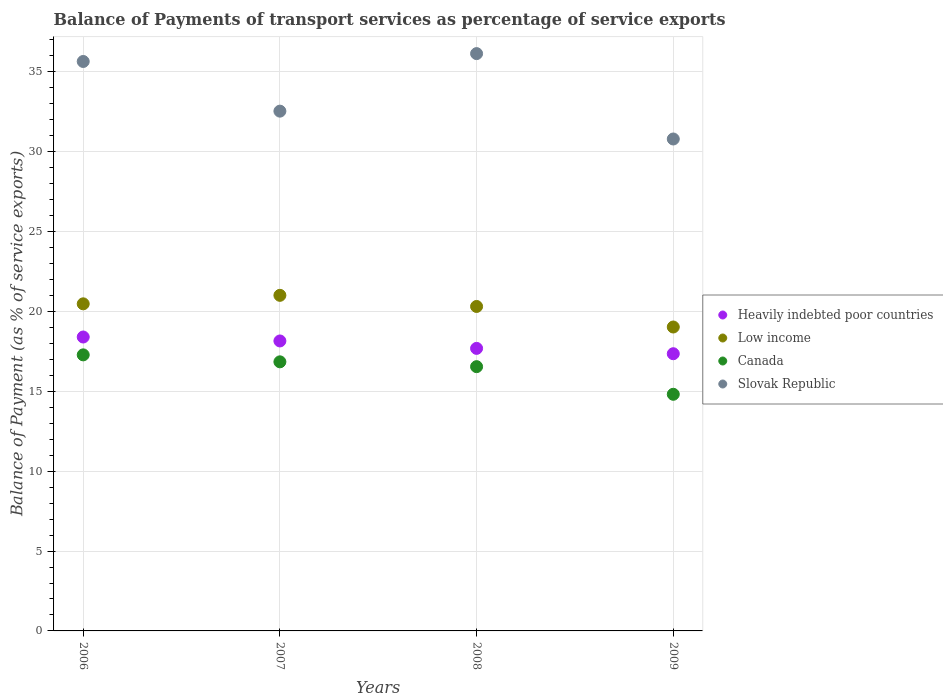How many different coloured dotlines are there?
Your response must be concise. 4. Is the number of dotlines equal to the number of legend labels?
Provide a short and direct response. Yes. What is the balance of payments of transport services in Slovak Republic in 2009?
Offer a very short reply. 30.8. Across all years, what is the maximum balance of payments of transport services in Canada?
Offer a terse response. 17.28. Across all years, what is the minimum balance of payments of transport services in Slovak Republic?
Make the answer very short. 30.8. In which year was the balance of payments of transport services in Heavily indebted poor countries maximum?
Your response must be concise. 2006. What is the total balance of payments of transport services in Canada in the graph?
Your answer should be compact. 65.49. What is the difference between the balance of payments of transport services in Low income in 2006 and that in 2008?
Your answer should be very brief. 0.16. What is the difference between the balance of payments of transport services in Slovak Republic in 2006 and the balance of payments of transport services in Canada in 2007?
Keep it short and to the point. 18.8. What is the average balance of payments of transport services in Heavily indebted poor countries per year?
Offer a very short reply. 17.9. In the year 2009, what is the difference between the balance of payments of transport services in Low income and balance of payments of transport services in Canada?
Keep it short and to the point. 4.21. In how many years, is the balance of payments of transport services in Slovak Republic greater than 8 %?
Offer a terse response. 4. What is the ratio of the balance of payments of transport services in Slovak Republic in 2007 to that in 2009?
Provide a short and direct response. 1.06. Is the balance of payments of transport services in Slovak Republic in 2007 less than that in 2009?
Give a very brief answer. No. What is the difference between the highest and the second highest balance of payments of transport services in Slovak Republic?
Give a very brief answer. 0.49. What is the difference between the highest and the lowest balance of payments of transport services in Heavily indebted poor countries?
Provide a short and direct response. 1.05. Is it the case that in every year, the sum of the balance of payments of transport services in Low income and balance of payments of transport services in Heavily indebted poor countries  is greater than the balance of payments of transport services in Slovak Republic?
Your answer should be very brief. Yes. Does the balance of payments of transport services in Heavily indebted poor countries monotonically increase over the years?
Offer a terse response. No. Is the balance of payments of transport services in Slovak Republic strictly greater than the balance of payments of transport services in Low income over the years?
Your answer should be very brief. Yes. Are the values on the major ticks of Y-axis written in scientific E-notation?
Offer a terse response. No. Does the graph contain any zero values?
Give a very brief answer. No. How many legend labels are there?
Provide a short and direct response. 4. What is the title of the graph?
Offer a terse response. Balance of Payments of transport services as percentage of service exports. What is the label or title of the Y-axis?
Your answer should be compact. Balance of Payment (as % of service exports). What is the Balance of Payment (as % of service exports) of Heavily indebted poor countries in 2006?
Keep it short and to the point. 18.4. What is the Balance of Payment (as % of service exports) of Low income in 2006?
Your response must be concise. 20.48. What is the Balance of Payment (as % of service exports) of Canada in 2006?
Ensure brevity in your answer.  17.28. What is the Balance of Payment (as % of service exports) of Slovak Republic in 2006?
Give a very brief answer. 35.65. What is the Balance of Payment (as % of service exports) of Heavily indebted poor countries in 2007?
Offer a very short reply. 18.15. What is the Balance of Payment (as % of service exports) in Low income in 2007?
Offer a very short reply. 21.01. What is the Balance of Payment (as % of service exports) of Canada in 2007?
Give a very brief answer. 16.85. What is the Balance of Payment (as % of service exports) in Slovak Republic in 2007?
Your response must be concise. 32.54. What is the Balance of Payment (as % of service exports) of Heavily indebted poor countries in 2008?
Give a very brief answer. 17.69. What is the Balance of Payment (as % of service exports) in Low income in 2008?
Make the answer very short. 20.31. What is the Balance of Payment (as % of service exports) of Canada in 2008?
Ensure brevity in your answer.  16.55. What is the Balance of Payment (as % of service exports) in Slovak Republic in 2008?
Keep it short and to the point. 36.14. What is the Balance of Payment (as % of service exports) of Heavily indebted poor countries in 2009?
Your answer should be very brief. 17.36. What is the Balance of Payment (as % of service exports) in Low income in 2009?
Ensure brevity in your answer.  19.03. What is the Balance of Payment (as % of service exports) in Canada in 2009?
Your answer should be very brief. 14.82. What is the Balance of Payment (as % of service exports) in Slovak Republic in 2009?
Make the answer very short. 30.8. Across all years, what is the maximum Balance of Payment (as % of service exports) in Heavily indebted poor countries?
Keep it short and to the point. 18.4. Across all years, what is the maximum Balance of Payment (as % of service exports) in Low income?
Your response must be concise. 21.01. Across all years, what is the maximum Balance of Payment (as % of service exports) in Canada?
Provide a short and direct response. 17.28. Across all years, what is the maximum Balance of Payment (as % of service exports) of Slovak Republic?
Offer a very short reply. 36.14. Across all years, what is the minimum Balance of Payment (as % of service exports) in Heavily indebted poor countries?
Make the answer very short. 17.36. Across all years, what is the minimum Balance of Payment (as % of service exports) of Low income?
Keep it short and to the point. 19.03. Across all years, what is the minimum Balance of Payment (as % of service exports) of Canada?
Make the answer very short. 14.82. Across all years, what is the minimum Balance of Payment (as % of service exports) of Slovak Republic?
Provide a succinct answer. 30.8. What is the total Balance of Payment (as % of service exports) in Heavily indebted poor countries in the graph?
Your response must be concise. 71.6. What is the total Balance of Payment (as % of service exports) in Low income in the graph?
Provide a short and direct response. 80.83. What is the total Balance of Payment (as % of service exports) of Canada in the graph?
Provide a short and direct response. 65.49. What is the total Balance of Payment (as % of service exports) in Slovak Republic in the graph?
Give a very brief answer. 135.14. What is the difference between the Balance of Payment (as % of service exports) in Heavily indebted poor countries in 2006 and that in 2007?
Offer a terse response. 0.25. What is the difference between the Balance of Payment (as % of service exports) of Low income in 2006 and that in 2007?
Offer a very short reply. -0.53. What is the difference between the Balance of Payment (as % of service exports) of Canada in 2006 and that in 2007?
Provide a short and direct response. 0.44. What is the difference between the Balance of Payment (as % of service exports) in Slovak Republic in 2006 and that in 2007?
Offer a terse response. 3.11. What is the difference between the Balance of Payment (as % of service exports) of Heavily indebted poor countries in 2006 and that in 2008?
Provide a succinct answer. 0.71. What is the difference between the Balance of Payment (as % of service exports) of Low income in 2006 and that in 2008?
Keep it short and to the point. 0.16. What is the difference between the Balance of Payment (as % of service exports) of Canada in 2006 and that in 2008?
Keep it short and to the point. 0.74. What is the difference between the Balance of Payment (as % of service exports) of Slovak Republic in 2006 and that in 2008?
Make the answer very short. -0.49. What is the difference between the Balance of Payment (as % of service exports) in Heavily indebted poor countries in 2006 and that in 2009?
Offer a very short reply. 1.05. What is the difference between the Balance of Payment (as % of service exports) of Low income in 2006 and that in 2009?
Your answer should be compact. 1.45. What is the difference between the Balance of Payment (as % of service exports) of Canada in 2006 and that in 2009?
Provide a succinct answer. 2.47. What is the difference between the Balance of Payment (as % of service exports) in Slovak Republic in 2006 and that in 2009?
Keep it short and to the point. 4.85. What is the difference between the Balance of Payment (as % of service exports) in Heavily indebted poor countries in 2007 and that in 2008?
Your answer should be very brief. 0.47. What is the difference between the Balance of Payment (as % of service exports) of Low income in 2007 and that in 2008?
Your answer should be very brief. 0.7. What is the difference between the Balance of Payment (as % of service exports) in Canada in 2007 and that in 2008?
Keep it short and to the point. 0.3. What is the difference between the Balance of Payment (as % of service exports) in Slovak Republic in 2007 and that in 2008?
Ensure brevity in your answer.  -3.6. What is the difference between the Balance of Payment (as % of service exports) of Heavily indebted poor countries in 2007 and that in 2009?
Provide a succinct answer. 0.8. What is the difference between the Balance of Payment (as % of service exports) in Low income in 2007 and that in 2009?
Your answer should be compact. 1.98. What is the difference between the Balance of Payment (as % of service exports) in Canada in 2007 and that in 2009?
Offer a very short reply. 2.03. What is the difference between the Balance of Payment (as % of service exports) of Slovak Republic in 2007 and that in 2009?
Make the answer very short. 1.74. What is the difference between the Balance of Payment (as % of service exports) in Heavily indebted poor countries in 2008 and that in 2009?
Provide a short and direct response. 0.33. What is the difference between the Balance of Payment (as % of service exports) of Low income in 2008 and that in 2009?
Your answer should be very brief. 1.29. What is the difference between the Balance of Payment (as % of service exports) of Canada in 2008 and that in 2009?
Keep it short and to the point. 1.73. What is the difference between the Balance of Payment (as % of service exports) of Slovak Republic in 2008 and that in 2009?
Give a very brief answer. 5.35. What is the difference between the Balance of Payment (as % of service exports) in Heavily indebted poor countries in 2006 and the Balance of Payment (as % of service exports) in Low income in 2007?
Your answer should be compact. -2.61. What is the difference between the Balance of Payment (as % of service exports) of Heavily indebted poor countries in 2006 and the Balance of Payment (as % of service exports) of Canada in 2007?
Your answer should be compact. 1.55. What is the difference between the Balance of Payment (as % of service exports) in Heavily indebted poor countries in 2006 and the Balance of Payment (as % of service exports) in Slovak Republic in 2007?
Keep it short and to the point. -14.14. What is the difference between the Balance of Payment (as % of service exports) in Low income in 2006 and the Balance of Payment (as % of service exports) in Canada in 2007?
Your response must be concise. 3.63. What is the difference between the Balance of Payment (as % of service exports) of Low income in 2006 and the Balance of Payment (as % of service exports) of Slovak Republic in 2007?
Offer a very short reply. -12.06. What is the difference between the Balance of Payment (as % of service exports) of Canada in 2006 and the Balance of Payment (as % of service exports) of Slovak Republic in 2007?
Your answer should be very brief. -15.26. What is the difference between the Balance of Payment (as % of service exports) in Heavily indebted poor countries in 2006 and the Balance of Payment (as % of service exports) in Low income in 2008?
Provide a succinct answer. -1.91. What is the difference between the Balance of Payment (as % of service exports) in Heavily indebted poor countries in 2006 and the Balance of Payment (as % of service exports) in Canada in 2008?
Offer a terse response. 1.86. What is the difference between the Balance of Payment (as % of service exports) of Heavily indebted poor countries in 2006 and the Balance of Payment (as % of service exports) of Slovak Republic in 2008?
Offer a very short reply. -17.74. What is the difference between the Balance of Payment (as % of service exports) of Low income in 2006 and the Balance of Payment (as % of service exports) of Canada in 2008?
Give a very brief answer. 3.93. What is the difference between the Balance of Payment (as % of service exports) of Low income in 2006 and the Balance of Payment (as % of service exports) of Slovak Republic in 2008?
Your answer should be compact. -15.67. What is the difference between the Balance of Payment (as % of service exports) in Canada in 2006 and the Balance of Payment (as % of service exports) in Slovak Republic in 2008?
Your answer should be very brief. -18.86. What is the difference between the Balance of Payment (as % of service exports) in Heavily indebted poor countries in 2006 and the Balance of Payment (as % of service exports) in Low income in 2009?
Your answer should be compact. -0.63. What is the difference between the Balance of Payment (as % of service exports) in Heavily indebted poor countries in 2006 and the Balance of Payment (as % of service exports) in Canada in 2009?
Offer a terse response. 3.59. What is the difference between the Balance of Payment (as % of service exports) in Heavily indebted poor countries in 2006 and the Balance of Payment (as % of service exports) in Slovak Republic in 2009?
Give a very brief answer. -12.4. What is the difference between the Balance of Payment (as % of service exports) in Low income in 2006 and the Balance of Payment (as % of service exports) in Canada in 2009?
Ensure brevity in your answer.  5.66. What is the difference between the Balance of Payment (as % of service exports) of Low income in 2006 and the Balance of Payment (as % of service exports) of Slovak Republic in 2009?
Provide a short and direct response. -10.32. What is the difference between the Balance of Payment (as % of service exports) of Canada in 2006 and the Balance of Payment (as % of service exports) of Slovak Republic in 2009?
Offer a very short reply. -13.52. What is the difference between the Balance of Payment (as % of service exports) in Heavily indebted poor countries in 2007 and the Balance of Payment (as % of service exports) in Low income in 2008?
Provide a short and direct response. -2.16. What is the difference between the Balance of Payment (as % of service exports) of Heavily indebted poor countries in 2007 and the Balance of Payment (as % of service exports) of Canada in 2008?
Your answer should be compact. 1.61. What is the difference between the Balance of Payment (as % of service exports) in Heavily indebted poor countries in 2007 and the Balance of Payment (as % of service exports) in Slovak Republic in 2008?
Provide a succinct answer. -17.99. What is the difference between the Balance of Payment (as % of service exports) in Low income in 2007 and the Balance of Payment (as % of service exports) in Canada in 2008?
Your response must be concise. 4.46. What is the difference between the Balance of Payment (as % of service exports) in Low income in 2007 and the Balance of Payment (as % of service exports) in Slovak Republic in 2008?
Provide a succinct answer. -15.13. What is the difference between the Balance of Payment (as % of service exports) of Canada in 2007 and the Balance of Payment (as % of service exports) of Slovak Republic in 2008?
Keep it short and to the point. -19.3. What is the difference between the Balance of Payment (as % of service exports) in Heavily indebted poor countries in 2007 and the Balance of Payment (as % of service exports) in Low income in 2009?
Your response must be concise. -0.87. What is the difference between the Balance of Payment (as % of service exports) of Heavily indebted poor countries in 2007 and the Balance of Payment (as % of service exports) of Canada in 2009?
Provide a short and direct response. 3.34. What is the difference between the Balance of Payment (as % of service exports) in Heavily indebted poor countries in 2007 and the Balance of Payment (as % of service exports) in Slovak Republic in 2009?
Provide a short and direct response. -12.64. What is the difference between the Balance of Payment (as % of service exports) of Low income in 2007 and the Balance of Payment (as % of service exports) of Canada in 2009?
Keep it short and to the point. 6.19. What is the difference between the Balance of Payment (as % of service exports) of Low income in 2007 and the Balance of Payment (as % of service exports) of Slovak Republic in 2009?
Keep it short and to the point. -9.79. What is the difference between the Balance of Payment (as % of service exports) of Canada in 2007 and the Balance of Payment (as % of service exports) of Slovak Republic in 2009?
Your response must be concise. -13.95. What is the difference between the Balance of Payment (as % of service exports) of Heavily indebted poor countries in 2008 and the Balance of Payment (as % of service exports) of Low income in 2009?
Give a very brief answer. -1.34. What is the difference between the Balance of Payment (as % of service exports) of Heavily indebted poor countries in 2008 and the Balance of Payment (as % of service exports) of Canada in 2009?
Offer a very short reply. 2.87. What is the difference between the Balance of Payment (as % of service exports) of Heavily indebted poor countries in 2008 and the Balance of Payment (as % of service exports) of Slovak Republic in 2009?
Keep it short and to the point. -13.11. What is the difference between the Balance of Payment (as % of service exports) in Low income in 2008 and the Balance of Payment (as % of service exports) in Canada in 2009?
Provide a short and direct response. 5.5. What is the difference between the Balance of Payment (as % of service exports) of Low income in 2008 and the Balance of Payment (as % of service exports) of Slovak Republic in 2009?
Make the answer very short. -10.48. What is the difference between the Balance of Payment (as % of service exports) in Canada in 2008 and the Balance of Payment (as % of service exports) in Slovak Republic in 2009?
Your response must be concise. -14.25. What is the average Balance of Payment (as % of service exports) in Heavily indebted poor countries per year?
Your answer should be compact. 17.9. What is the average Balance of Payment (as % of service exports) of Low income per year?
Give a very brief answer. 20.21. What is the average Balance of Payment (as % of service exports) in Canada per year?
Provide a succinct answer. 16.37. What is the average Balance of Payment (as % of service exports) of Slovak Republic per year?
Your answer should be very brief. 33.78. In the year 2006, what is the difference between the Balance of Payment (as % of service exports) in Heavily indebted poor countries and Balance of Payment (as % of service exports) in Low income?
Provide a short and direct response. -2.08. In the year 2006, what is the difference between the Balance of Payment (as % of service exports) of Heavily indebted poor countries and Balance of Payment (as % of service exports) of Canada?
Your answer should be very brief. 1.12. In the year 2006, what is the difference between the Balance of Payment (as % of service exports) of Heavily indebted poor countries and Balance of Payment (as % of service exports) of Slovak Republic?
Provide a succinct answer. -17.25. In the year 2006, what is the difference between the Balance of Payment (as % of service exports) in Low income and Balance of Payment (as % of service exports) in Canada?
Your response must be concise. 3.2. In the year 2006, what is the difference between the Balance of Payment (as % of service exports) of Low income and Balance of Payment (as % of service exports) of Slovak Republic?
Make the answer very short. -15.17. In the year 2006, what is the difference between the Balance of Payment (as % of service exports) of Canada and Balance of Payment (as % of service exports) of Slovak Republic?
Ensure brevity in your answer.  -18.37. In the year 2007, what is the difference between the Balance of Payment (as % of service exports) in Heavily indebted poor countries and Balance of Payment (as % of service exports) in Low income?
Keep it short and to the point. -2.86. In the year 2007, what is the difference between the Balance of Payment (as % of service exports) of Heavily indebted poor countries and Balance of Payment (as % of service exports) of Canada?
Provide a succinct answer. 1.31. In the year 2007, what is the difference between the Balance of Payment (as % of service exports) in Heavily indebted poor countries and Balance of Payment (as % of service exports) in Slovak Republic?
Your answer should be very brief. -14.39. In the year 2007, what is the difference between the Balance of Payment (as % of service exports) in Low income and Balance of Payment (as % of service exports) in Canada?
Keep it short and to the point. 4.16. In the year 2007, what is the difference between the Balance of Payment (as % of service exports) of Low income and Balance of Payment (as % of service exports) of Slovak Republic?
Offer a very short reply. -11.53. In the year 2007, what is the difference between the Balance of Payment (as % of service exports) in Canada and Balance of Payment (as % of service exports) in Slovak Republic?
Your answer should be compact. -15.69. In the year 2008, what is the difference between the Balance of Payment (as % of service exports) of Heavily indebted poor countries and Balance of Payment (as % of service exports) of Low income?
Offer a very short reply. -2.62. In the year 2008, what is the difference between the Balance of Payment (as % of service exports) in Heavily indebted poor countries and Balance of Payment (as % of service exports) in Canada?
Provide a succinct answer. 1.14. In the year 2008, what is the difference between the Balance of Payment (as % of service exports) in Heavily indebted poor countries and Balance of Payment (as % of service exports) in Slovak Republic?
Your answer should be very brief. -18.46. In the year 2008, what is the difference between the Balance of Payment (as % of service exports) of Low income and Balance of Payment (as % of service exports) of Canada?
Provide a short and direct response. 3.77. In the year 2008, what is the difference between the Balance of Payment (as % of service exports) in Low income and Balance of Payment (as % of service exports) in Slovak Republic?
Provide a succinct answer. -15.83. In the year 2008, what is the difference between the Balance of Payment (as % of service exports) of Canada and Balance of Payment (as % of service exports) of Slovak Republic?
Offer a very short reply. -19.6. In the year 2009, what is the difference between the Balance of Payment (as % of service exports) of Heavily indebted poor countries and Balance of Payment (as % of service exports) of Low income?
Offer a very short reply. -1.67. In the year 2009, what is the difference between the Balance of Payment (as % of service exports) in Heavily indebted poor countries and Balance of Payment (as % of service exports) in Canada?
Your response must be concise. 2.54. In the year 2009, what is the difference between the Balance of Payment (as % of service exports) in Heavily indebted poor countries and Balance of Payment (as % of service exports) in Slovak Republic?
Offer a terse response. -13.44. In the year 2009, what is the difference between the Balance of Payment (as % of service exports) in Low income and Balance of Payment (as % of service exports) in Canada?
Keep it short and to the point. 4.21. In the year 2009, what is the difference between the Balance of Payment (as % of service exports) of Low income and Balance of Payment (as % of service exports) of Slovak Republic?
Offer a very short reply. -11.77. In the year 2009, what is the difference between the Balance of Payment (as % of service exports) in Canada and Balance of Payment (as % of service exports) in Slovak Republic?
Your answer should be very brief. -15.98. What is the ratio of the Balance of Payment (as % of service exports) of Heavily indebted poor countries in 2006 to that in 2007?
Provide a succinct answer. 1.01. What is the ratio of the Balance of Payment (as % of service exports) of Low income in 2006 to that in 2007?
Make the answer very short. 0.97. What is the ratio of the Balance of Payment (as % of service exports) in Canada in 2006 to that in 2007?
Offer a terse response. 1.03. What is the ratio of the Balance of Payment (as % of service exports) in Slovak Republic in 2006 to that in 2007?
Your answer should be very brief. 1.1. What is the ratio of the Balance of Payment (as % of service exports) in Heavily indebted poor countries in 2006 to that in 2008?
Provide a succinct answer. 1.04. What is the ratio of the Balance of Payment (as % of service exports) of Low income in 2006 to that in 2008?
Offer a terse response. 1.01. What is the ratio of the Balance of Payment (as % of service exports) in Canada in 2006 to that in 2008?
Make the answer very short. 1.04. What is the ratio of the Balance of Payment (as % of service exports) in Slovak Republic in 2006 to that in 2008?
Provide a short and direct response. 0.99. What is the ratio of the Balance of Payment (as % of service exports) in Heavily indebted poor countries in 2006 to that in 2009?
Ensure brevity in your answer.  1.06. What is the ratio of the Balance of Payment (as % of service exports) of Low income in 2006 to that in 2009?
Make the answer very short. 1.08. What is the ratio of the Balance of Payment (as % of service exports) of Canada in 2006 to that in 2009?
Offer a terse response. 1.17. What is the ratio of the Balance of Payment (as % of service exports) of Slovak Republic in 2006 to that in 2009?
Keep it short and to the point. 1.16. What is the ratio of the Balance of Payment (as % of service exports) in Heavily indebted poor countries in 2007 to that in 2008?
Your response must be concise. 1.03. What is the ratio of the Balance of Payment (as % of service exports) of Low income in 2007 to that in 2008?
Keep it short and to the point. 1.03. What is the ratio of the Balance of Payment (as % of service exports) of Canada in 2007 to that in 2008?
Offer a very short reply. 1.02. What is the ratio of the Balance of Payment (as % of service exports) in Slovak Republic in 2007 to that in 2008?
Your response must be concise. 0.9. What is the ratio of the Balance of Payment (as % of service exports) in Heavily indebted poor countries in 2007 to that in 2009?
Provide a succinct answer. 1.05. What is the ratio of the Balance of Payment (as % of service exports) of Low income in 2007 to that in 2009?
Make the answer very short. 1.1. What is the ratio of the Balance of Payment (as % of service exports) in Canada in 2007 to that in 2009?
Your answer should be very brief. 1.14. What is the ratio of the Balance of Payment (as % of service exports) in Slovak Republic in 2007 to that in 2009?
Offer a very short reply. 1.06. What is the ratio of the Balance of Payment (as % of service exports) in Heavily indebted poor countries in 2008 to that in 2009?
Keep it short and to the point. 1.02. What is the ratio of the Balance of Payment (as % of service exports) in Low income in 2008 to that in 2009?
Provide a short and direct response. 1.07. What is the ratio of the Balance of Payment (as % of service exports) in Canada in 2008 to that in 2009?
Offer a very short reply. 1.12. What is the ratio of the Balance of Payment (as % of service exports) in Slovak Republic in 2008 to that in 2009?
Your answer should be very brief. 1.17. What is the difference between the highest and the second highest Balance of Payment (as % of service exports) of Heavily indebted poor countries?
Keep it short and to the point. 0.25. What is the difference between the highest and the second highest Balance of Payment (as % of service exports) of Low income?
Your answer should be compact. 0.53. What is the difference between the highest and the second highest Balance of Payment (as % of service exports) of Canada?
Offer a terse response. 0.44. What is the difference between the highest and the second highest Balance of Payment (as % of service exports) in Slovak Republic?
Offer a very short reply. 0.49. What is the difference between the highest and the lowest Balance of Payment (as % of service exports) of Heavily indebted poor countries?
Offer a very short reply. 1.05. What is the difference between the highest and the lowest Balance of Payment (as % of service exports) in Low income?
Offer a terse response. 1.98. What is the difference between the highest and the lowest Balance of Payment (as % of service exports) in Canada?
Provide a succinct answer. 2.47. What is the difference between the highest and the lowest Balance of Payment (as % of service exports) in Slovak Republic?
Offer a terse response. 5.35. 